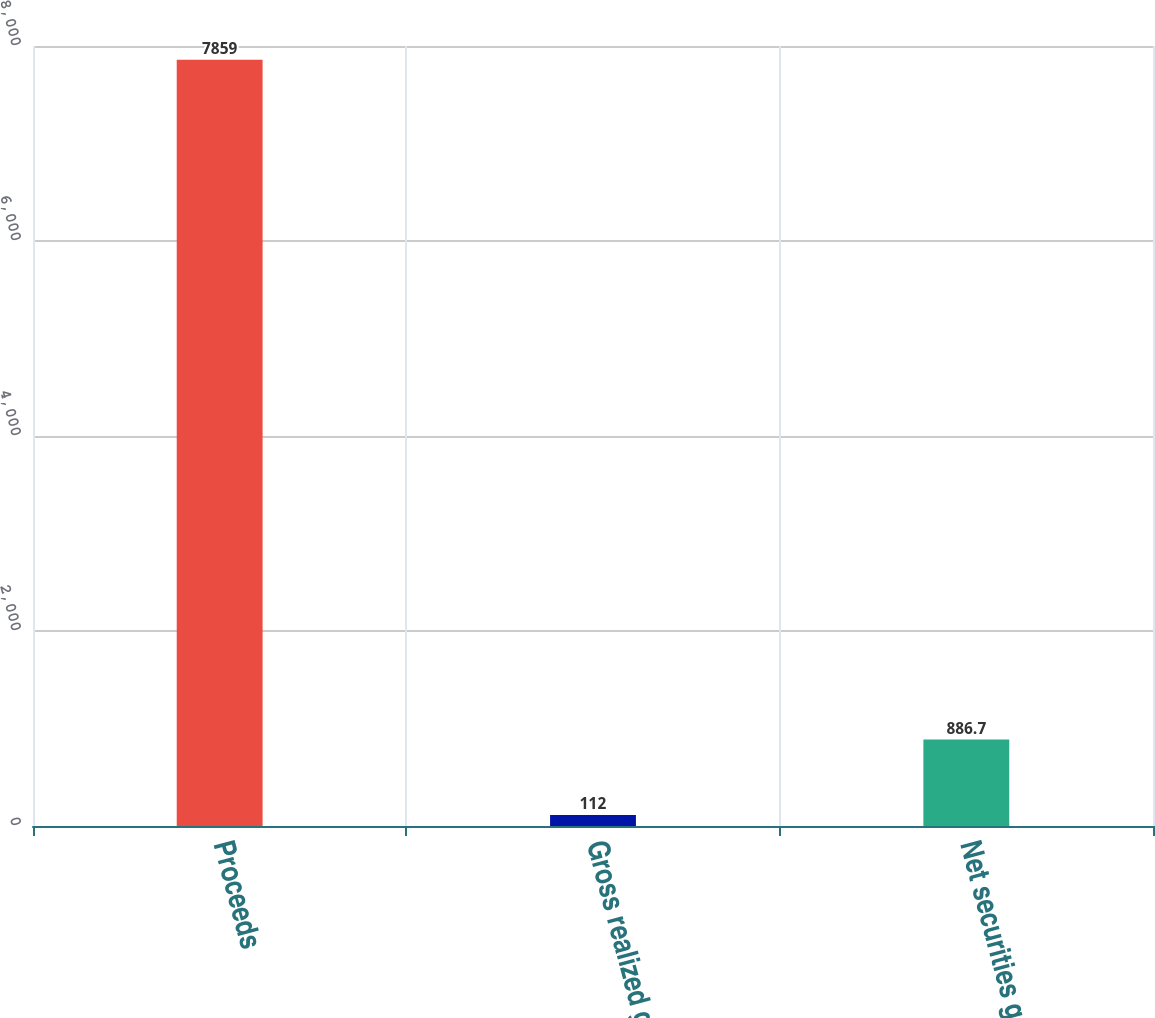<chart> <loc_0><loc_0><loc_500><loc_500><bar_chart><fcel>Proceeds<fcel>Gross realized gains<fcel>Net securities gains<nl><fcel>7859<fcel>112<fcel>886.7<nl></chart> 